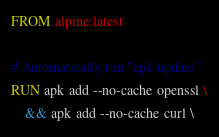<code> <loc_0><loc_0><loc_500><loc_500><_Dockerfile_>FROM alpine:latest

# Automatically run "apk update"
RUN apk add --no-cache openssl \
    && apk add --no-cache curl \</code> 